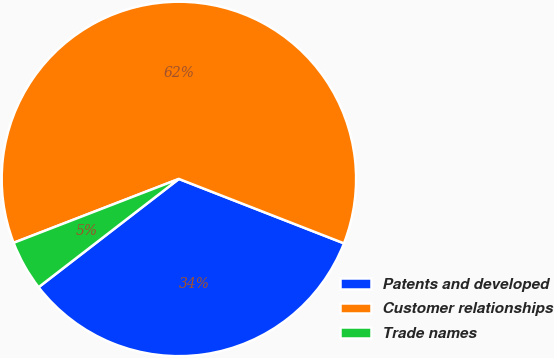Convert chart to OTSL. <chart><loc_0><loc_0><loc_500><loc_500><pie_chart><fcel>Patents and developed<fcel>Customer relationships<fcel>Trade names<nl><fcel>33.62%<fcel>61.79%<fcel>4.59%<nl></chart> 